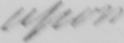Can you tell me what this handwritten text says? upon 